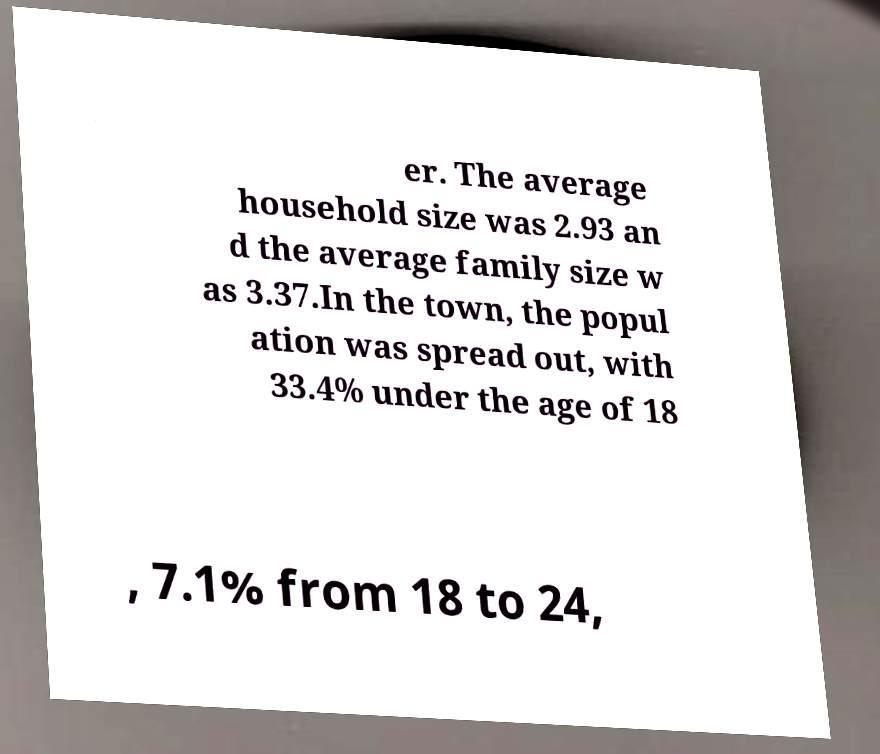What messages or text are displayed in this image? I need them in a readable, typed format. er. The average household size was 2.93 an d the average family size w as 3.37.In the town, the popul ation was spread out, with 33.4% under the age of 18 , 7.1% from 18 to 24, 